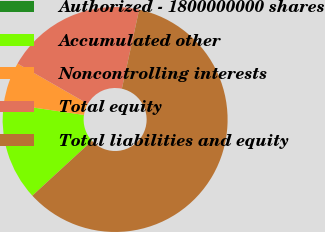Convert chart. <chart><loc_0><loc_0><loc_500><loc_500><pie_chart><fcel>Authorized - 1800000000 shares<fcel>Accumulated other<fcel>Noncontrolling interests<fcel>Total equity<fcel>Total liabilities and equity<nl><fcel>0.0%<fcel>14.16%<fcel>5.97%<fcel>20.14%<fcel>59.73%<nl></chart> 